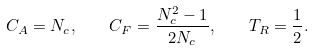<formula> <loc_0><loc_0><loc_500><loc_500>C _ { A } = N _ { c } , \quad C _ { F } = \frac { N _ { c } ^ { 2 } - 1 } { 2 N _ { c } } , \quad T _ { R } = \frac { 1 } { 2 } .</formula> 